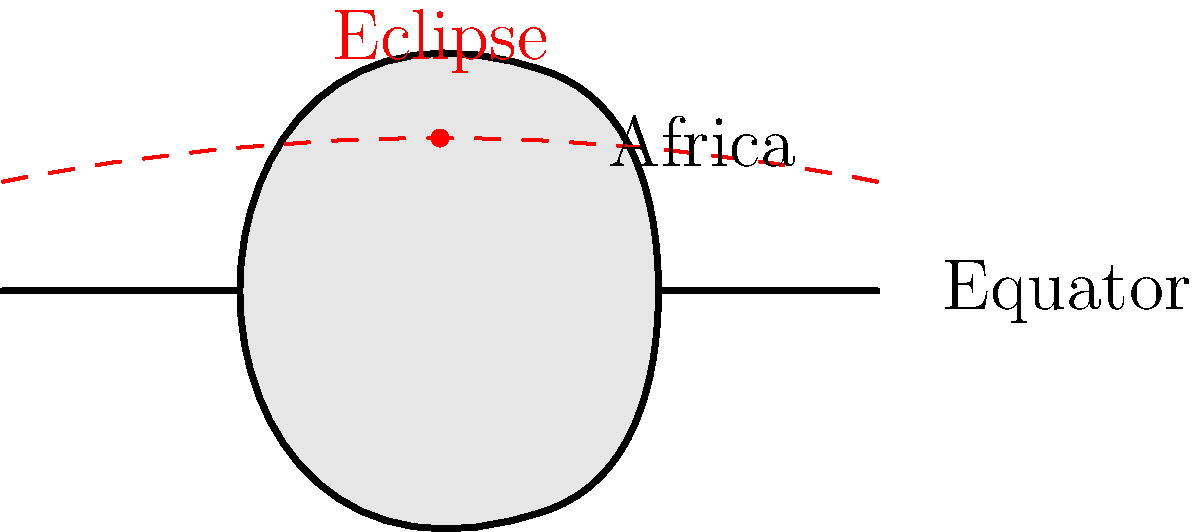As an African tribal leader collaborating with foreign diplomats to boost the local economy, you're organizing an astronomy-themed cultural event. How often can you expect to witness a total solar eclipse visible from your location in Africa, assuming you're situated near the equator? To answer this question, let's break down the factors involved:

1. Solar eclipses occur when the Moon passes between the Earth and the Sun, casting a shadow on Earth's surface.

2. Total solar eclipses are rarer than partial eclipses because they require perfect alignment of the Sun, Moon, and Earth.

3. On average, a total solar eclipse occurs somewhere on Earth about once every 18 months.

4. However, for a specific location, the frequency is much lower due to the narrow path of totality.

5. The path of totality for a solar eclipse is typically only about 100-200 km wide.

6. Africa, being a large continent straddling the equator, has a higher chance of experiencing total solar eclipses compared to smaller landmasses.

7. For any given location near the equator in Africa:
   - The odds of being in the path of totality are higher than locations far from the equator.
   - However, it's still a rare event for a specific spot.

8. On average, a particular location on Earth will experience a total solar eclipse once every 360 to 410 years.

9. Given Africa's size and position, we can estimate that a specific location near the equator in Africa might experience a total solar eclipse slightly more frequently, perhaps once every 300 to 350 years.

Therefore, while solar eclipses occur relatively frequently on a global scale, for your specific location in Africa, they are still quite rare events.
Answer: Once every 300-350 years, on average. 